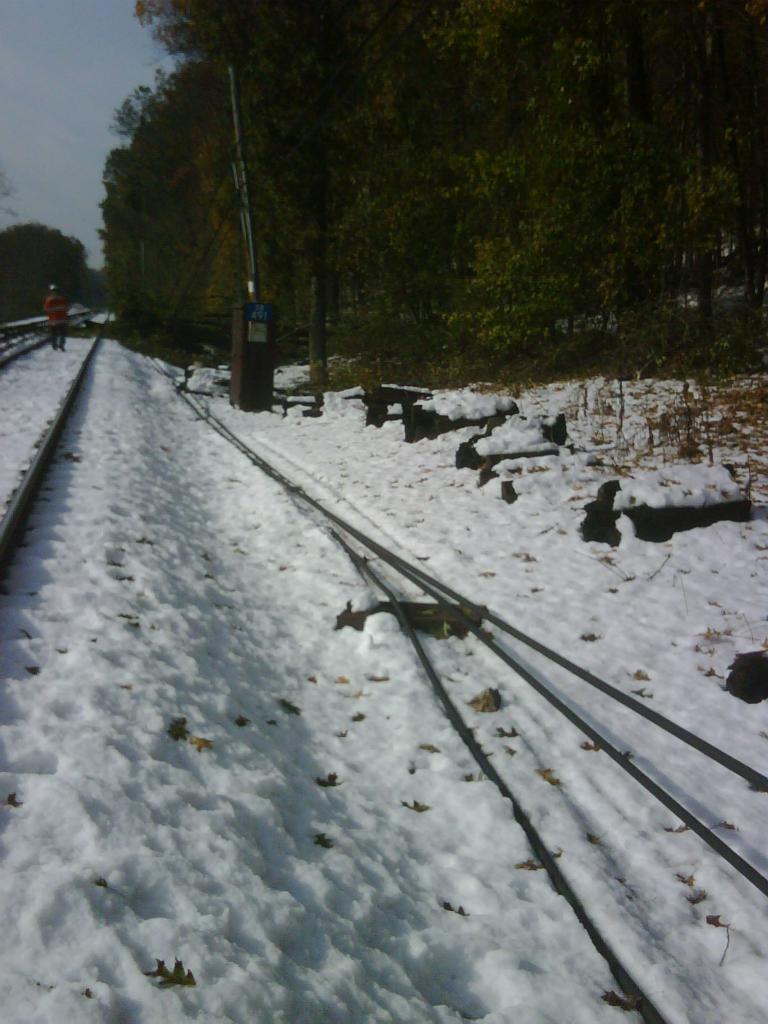How would you summarize this image in a sentence or two? In this picture we can see a place covered with snow. It has trees on either side. 